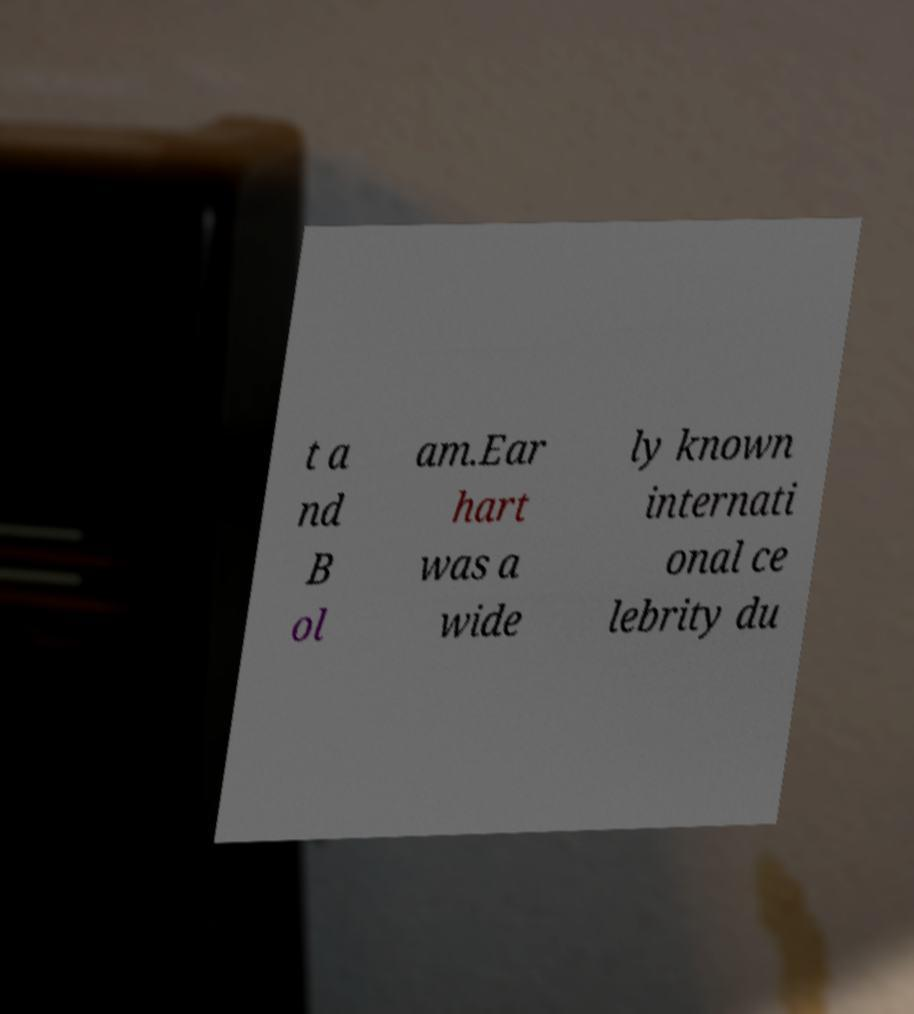Could you extract and type out the text from this image? t a nd B ol am.Ear hart was a wide ly known internati onal ce lebrity du 